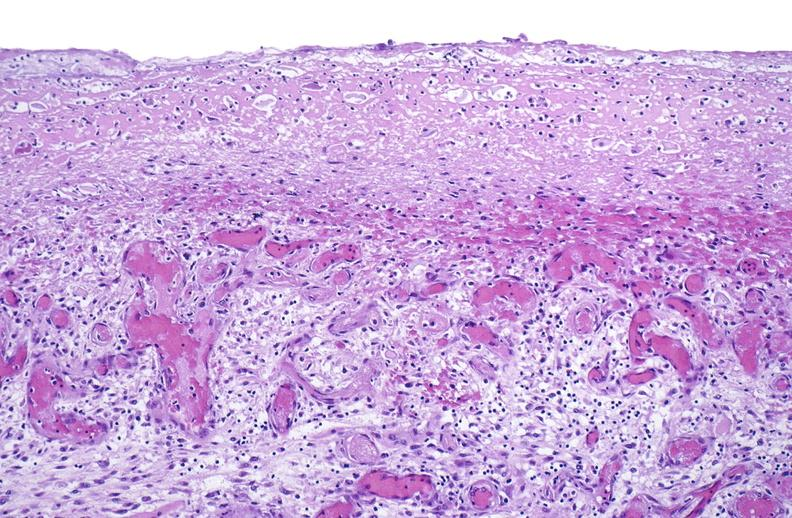what does this image show?
Answer the question using a single word or phrase. Tracheotomy site 